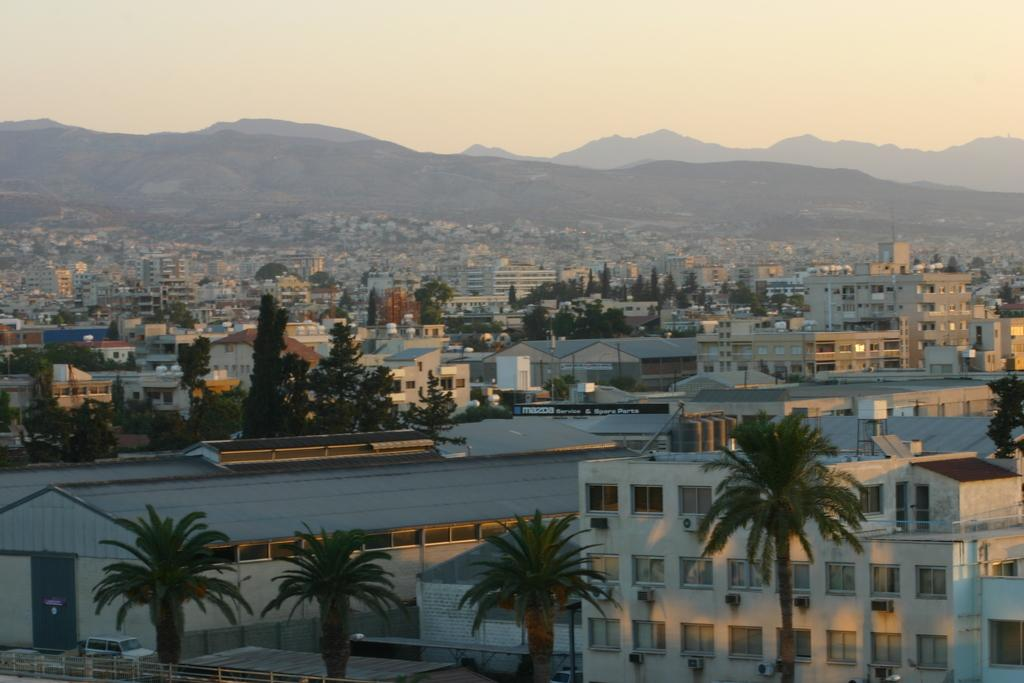What type of structures can be seen in the image? There are buildings in the image. What natural elements are present in the image? There are trees and mountains in the image. What man-made object can be seen in the image? There is a fence in the image. What mode of transportation is visible in the image? There is a vehicle in the image. What part of the natural environment is visible in the background of the image? The sky is visible in the background of the image. Can you tell me how many bears are visible in the image? There are no bears present in the image. What phase of the moon can be seen in the image? There is no moon visible in the image. 